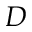Convert formula to latex. <formula><loc_0><loc_0><loc_500><loc_500>D</formula> 